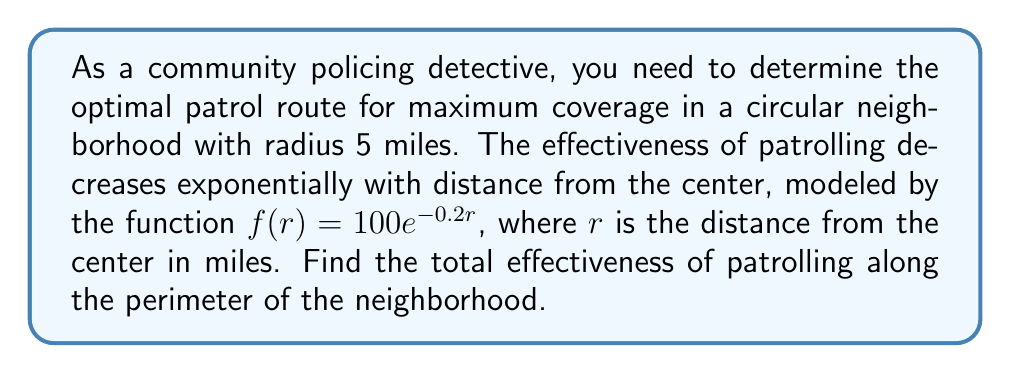Solve this math problem. To solve this problem, we need to use the concept of line integrals. The steps are as follows:

1) The effectiveness function is given as $f(r) = 100e^{-0.2r}$.

2) We need to integrate this function along the perimeter of the circle. The parametric equations for a circle with radius 5 are:
   $x = 5\cos\theta$
   $y = 5\sin\theta$
   where $0 \leq \theta \leq 2\pi$

3) The line integral formula is:
   $$\int_C f(x,y) ds = \int_a^b f(x(t),y(t)) \sqrt{\left(\frac{dx}{dt}\right)^2 + \left(\frac{dy}{dt}\right)^2} dt$$

4) In our case:
   $r = \sqrt{x^2 + y^2} = 5$
   $\frac{dx}{d\theta} = -5\sin\theta$
   $\frac{dy}{d\theta} = 5\cos\theta$

5) Substituting into the line integral formula:
   $$\int_0^{2\pi} 100e^{-0.2(5)} \sqrt{(-5\sin\theta)^2 + (5\cos\theta)^2} d\theta$$

6) Simplify:
   $$100e^{-1} \int_0^{2\pi} 5 d\theta$$

7) Evaluate:
   $$500e^{-1} \cdot 2\pi$$

8) Calculate the final value:
   $$500 \cdot 0.368 \cdot 2\pi \approx 1156.6$$
Answer: $500e^{-1} \cdot 2\pi \approx 1156.6$ 